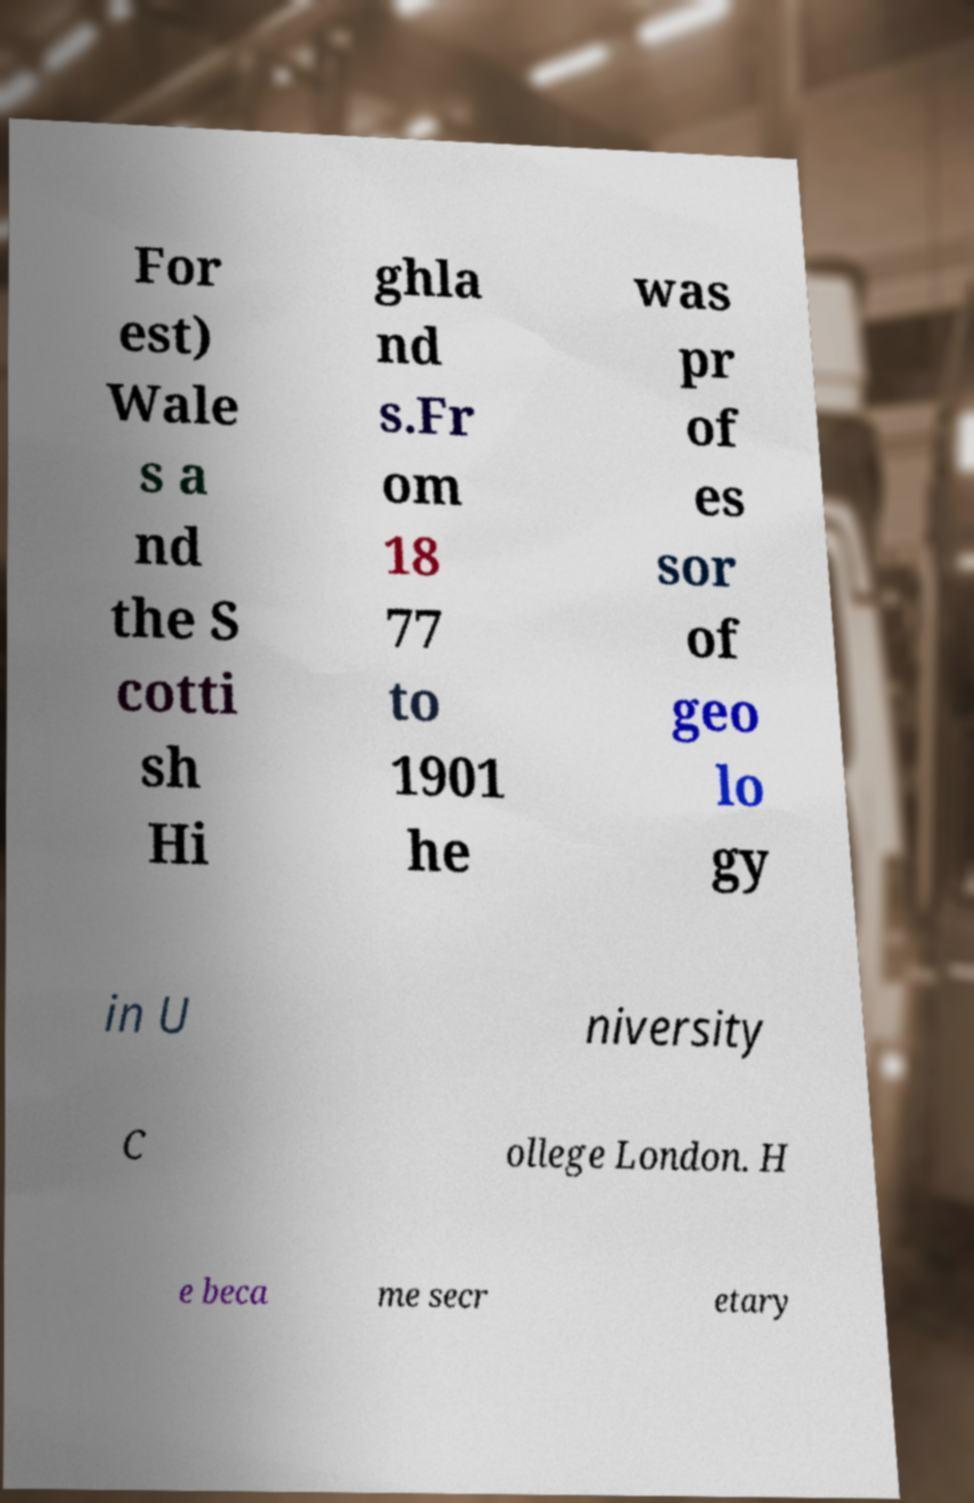For documentation purposes, I need the text within this image transcribed. Could you provide that? For est) Wale s a nd the S cotti sh Hi ghla nd s.Fr om 18 77 to 1901 he was pr of es sor of geo lo gy in U niversity C ollege London. H e beca me secr etary 